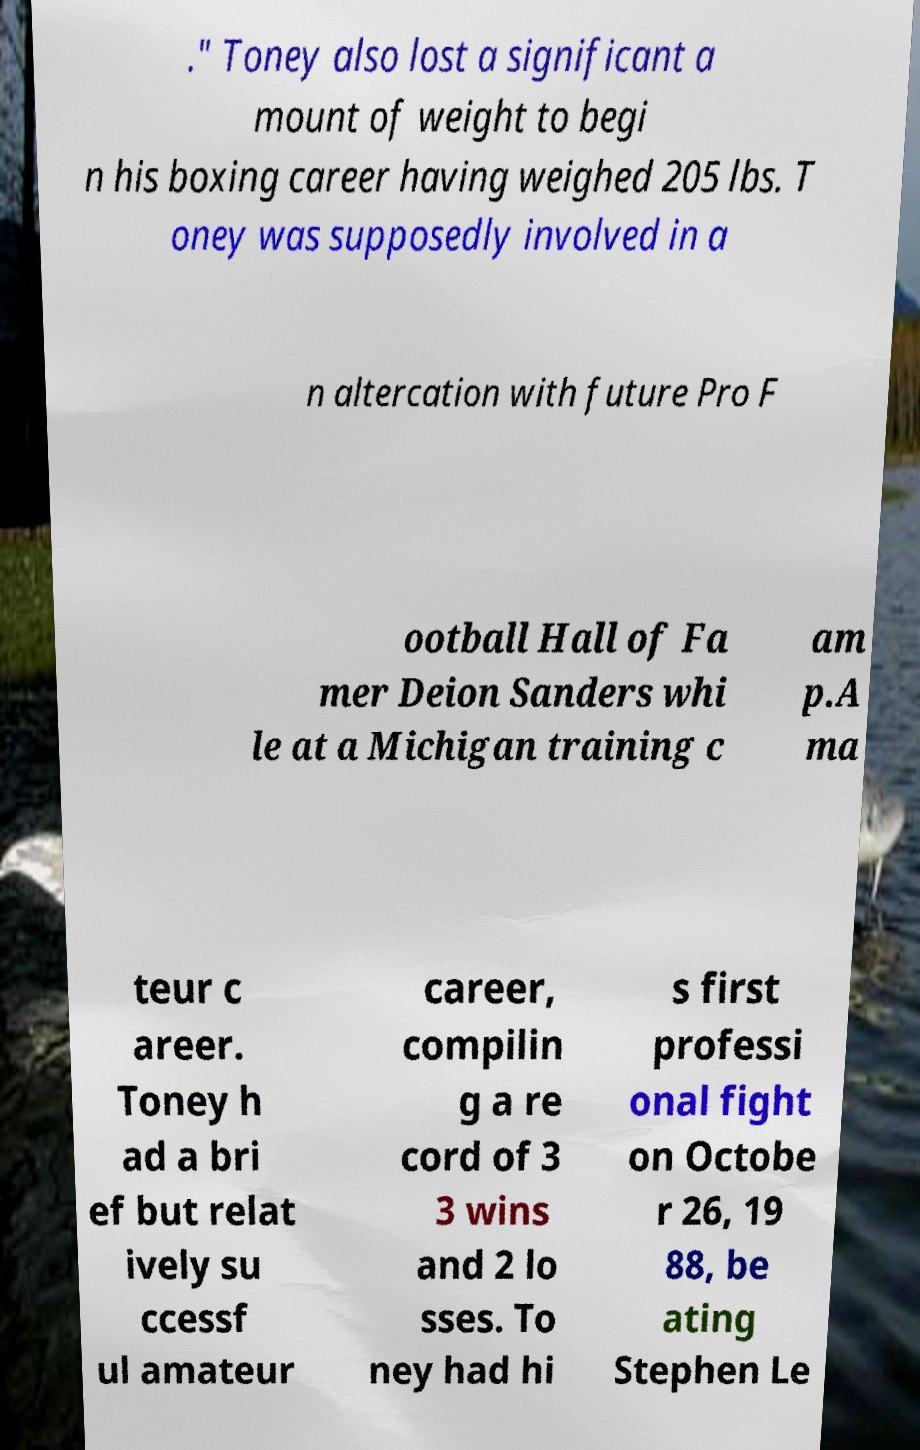Please read and relay the text visible in this image. What does it say? ." Toney also lost a significant a mount of weight to begi n his boxing career having weighed 205 lbs. T oney was supposedly involved in a n altercation with future Pro F ootball Hall of Fa mer Deion Sanders whi le at a Michigan training c am p.A ma teur c areer. Toney h ad a bri ef but relat ively su ccessf ul amateur career, compilin g a re cord of 3 3 wins and 2 lo sses. To ney had hi s first professi onal fight on Octobe r 26, 19 88, be ating Stephen Le 